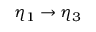Convert formula to latex. <formula><loc_0><loc_0><loc_500><loc_500>\eta _ { 1 } \rightarrow \eta _ { 3 }</formula> 